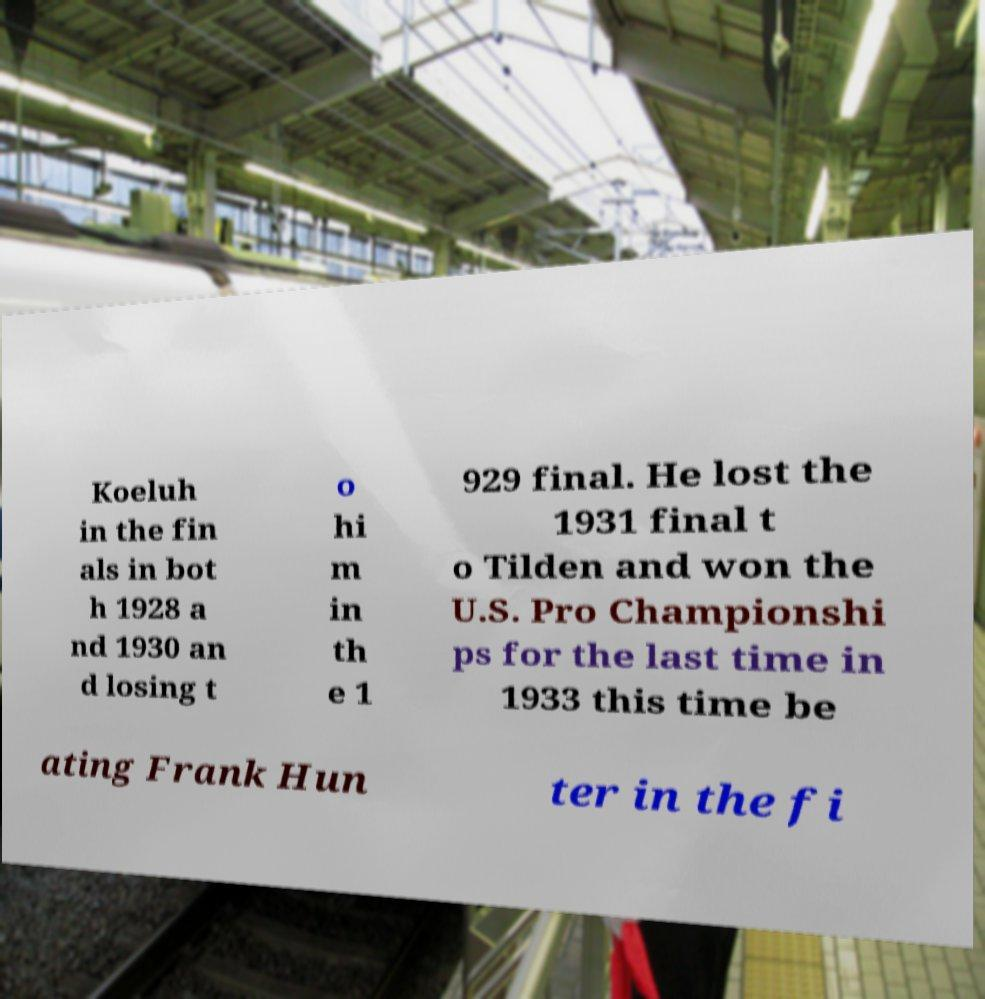What messages or text are displayed in this image? I need them in a readable, typed format. Koeluh in the fin als in bot h 1928 a nd 1930 an d losing t o hi m in th e 1 929 final. He lost the 1931 final t o Tilden and won the U.S. Pro Championshi ps for the last time in 1933 this time be ating Frank Hun ter in the fi 